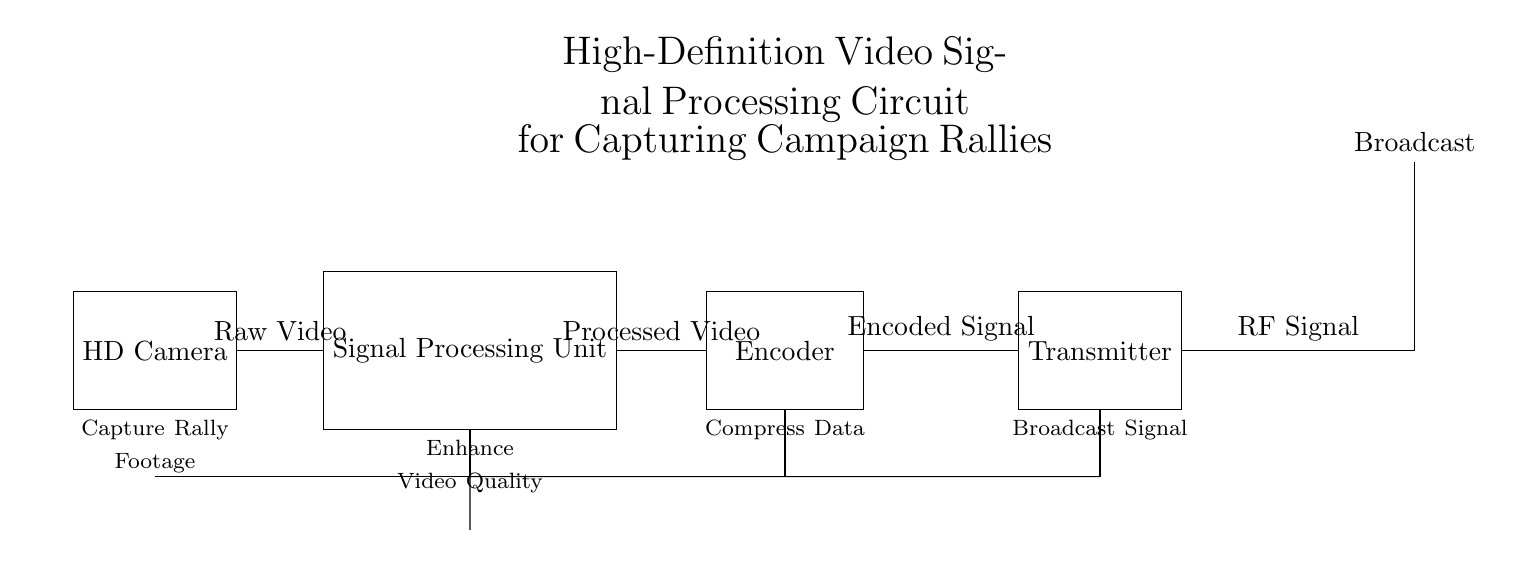What is the initial component used to capture video? The HD Camera is the first component in the circuit that captures the raw video footage from the campaign rally.
Answer: HD Camera What does the Signal Processing Unit do? The Signal Processing Unit enhances video quality by processing the raw video signal received from the HD Camera to improve clarity and detail.
Answer: Enhance Video Quality How many main components are in the circuit? There are five main components in the circuit: the HD Camera, Signal Processing Unit, Encoder, Transmitter, and the Antenna.
Answer: Five What type of signal does the Transmitter output? The Transmitter outputs an RF Signal, which is the radio frequency signal capable of being broadcasted for transmission.
Answer: RF Signal What is the function of the Encoder? The Encoder compresses data to make the video signal easier to transmit by reducing the size of the video files while maintaining quality.
Answer: Compress Data Explain the flow of video data through the circuit. The video data starts at the HD Camera, which captures raw footage, then it's sent to the Signal Processing Unit to enhance it. After processing, the video is sent to the Encoder for compression. Finally, the compressed video is transmitted via the Transmitter as an RF Signal through the Antenna for broadcast.
Answer: From Camera to SPU to Encoder to Transmitter What is the role of the Antenna in this circuit? The Antenna's role is to broadcast the RF Signal emitted by the Transmitter into the surrounding area, enabling the captured video to be transmitted wirelessly for viewers to receive.
Answer: Broadcast 